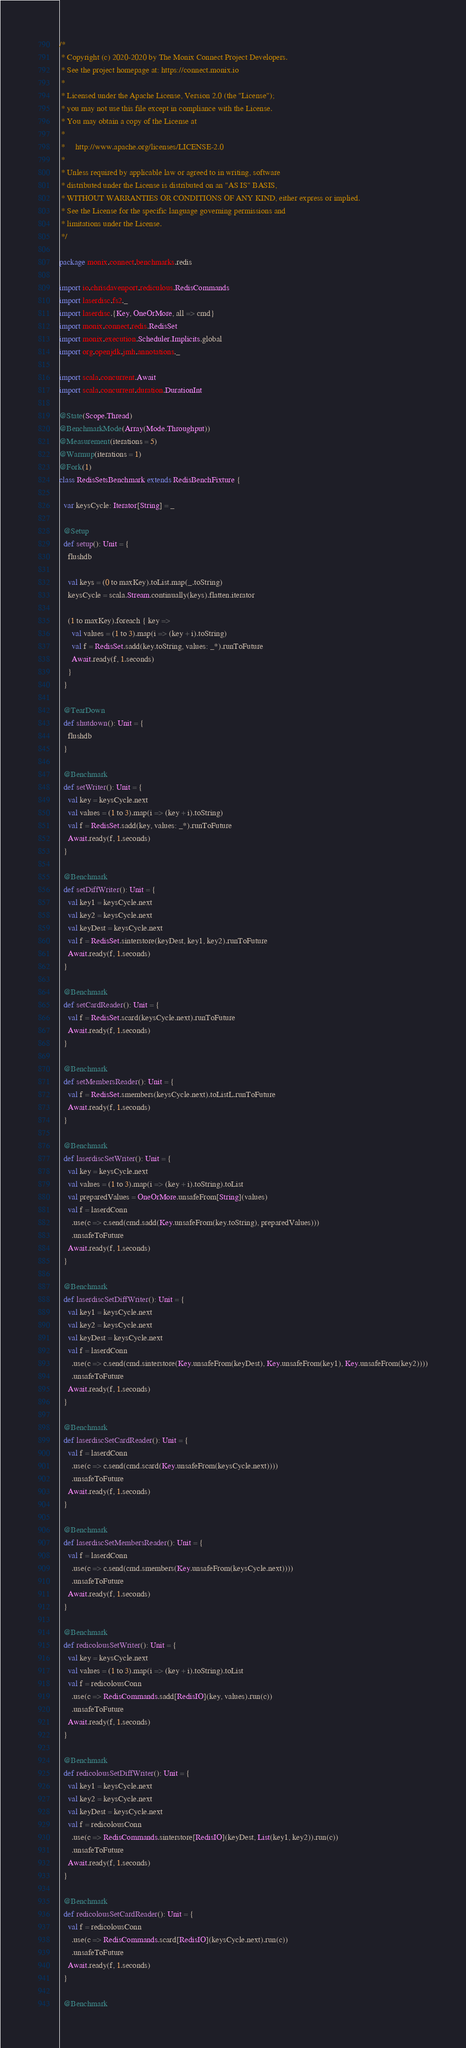Convert code to text. <code><loc_0><loc_0><loc_500><loc_500><_Scala_>/*
 * Copyright (c) 2020-2020 by The Monix Connect Project Developers.
 * See the project homepage at: https://connect.monix.io
 *
 * Licensed under the Apache License, Version 2.0 (the "License");
 * you may not use this file except in compliance with the License.
 * You may obtain a copy of the License at
 *
 *     http://www.apache.org/licenses/LICENSE-2.0
 *
 * Unless required by applicable law or agreed to in writing, software
 * distributed under the License is distributed on an "AS IS" BASIS,
 * WITHOUT WARRANTIES OR CONDITIONS OF ANY KIND, either express or implied.
 * See the License for the specific language governing permissions and
 * limitations under the License.
 */

package monix.connect.benchmarks.redis

import io.chrisdavenport.rediculous.RedisCommands
import laserdisc.fs2._
import laserdisc.{Key, OneOrMore, all => cmd}
import monix.connect.redis.RedisSet
import monix.execution.Scheduler.Implicits.global
import org.openjdk.jmh.annotations._

import scala.concurrent.Await
import scala.concurrent.duration.DurationInt

@State(Scope.Thread)
@BenchmarkMode(Array(Mode.Throughput))
@Measurement(iterations = 5)
@Warmup(iterations = 1)
@Fork(1)
class RedisSetsBenchmark extends RedisBenchFixture {

  var keysCycle: Iterator[String] = _

  @Setup
  def setup(): Unit = {
    flushdb

    val keys = (0 to maxKey).toList.map(_.toString)
    keysCycle = scala.Stream.continually(keys).flatten.iterator

    (1 to maxKey).foreach { key =>
      val values = (1 to 3).map(i => (key + i).toString)
      val f = RedisSet.sadd(key.toString, values: _*).runToFuture
      Await.ready(f, 1.seconds)
    }
  }

  @TearDown
  def shutdown(): Unit = {
    flushdb
  }

  @Benchmark
  def setWriter(): Unit = {
    val key = keysCycle.next
    val values = (1 to 3).map(i => (key + i).toString)
    val f = RedisSet.sadd(key, values: _*).runToFuture
    Await.ready(f, 1.seconds)
  }

  @Benchmark
  def setDiffWriter(): Unit = {
    val key1 = keysCycle.next
    val key2 = keysCycle.next
    val keyDest = keysCycle.next
    val f = RedisSet.sinterstore(keyDest, key1, key2).runToFuture
    Await.ready(f, 1.seconds)
  }

  @Benchmark
  def setCardReader(): Unit = {
    val f = RedisSet.scard(keysCycle.next).runToFuture
    Await.ready(f, 1.seconds)
  }

  @Benchmark
  def setMembersReader(): Unit = {
    val f = RedisSet.smembers(keysCycle.next).toListL.runToFuture
    Await.ready(f, 1.seconds)
  }

  @Benchmark
  def laserdiscSetWriter(): Unit = {
    val key = keysCycle.next
    val values = (1 to 3).map(i => (key + i).toString).toList
    val preparedValues = OneOrMore.unsafeFrom[String](values)
    val f = laserdConn
      .use(c => c.send(cmd.sadd(Key.unsafeFrom(key.toString), preparedValues)))
      .unsafeToFuture
    Await.ready(f, 1.seconds)
  }

  @Benchmark
  def laserdiscSetDiffWriter(): Unit = {
    val key1 = keysCycle.next
    val key2 = keysCycle.next
    val keyDest = keysCycle.next
    val f = laserdConn
      .use(c => c.send(cmd.sinterstore(Key.unsafeFrom(keyDest), Key.unsafeFrom(key1), Key.unsafeFrom(key2))))
      .unsafeToFuture
    Await.ready(f, 1.seconds)
  }

  @Benchmark
  def laserdiscSetCardReader(): Unit = {
    val f = laserdConn
      .use(c => c.send(cmd.scard(Key.unsafeFrom(keysCycle.next))))
      .unsafeToFuture
    Await.ready(f, 1.seconds)
  }

  @Benchmark
  def laserdiscSetMembersReader(): Unit = {
    val f = laserdConn
      .use(c => c.send(cmd.smembers(Key.unsafeFrom(keysCycle.next))))
      .unsafeToFuture
    Await.ready(f, 1.seconds)
  }

  @Benchmark
  def redicolousSetWriter(): Unit = {
    val key = keysCycle.next
    val values = (1 to 3).map(i => (key + i).toString).toList
    val f = redicolousConn
      .use(c => RedisCommands.sadd[RedisIO](key, values).run(c))
      .unsafeToFuture
    Await.ready(f, 1.seconds)
  }

  @Benchmark
  def redicolousSetDiffWriter(): Unit = {
    val key1 = keysCycle.next
    val key2 = keysCycle.next
    val keyDest = keysCycle.next
    val f = redicolousConn
      .use(c => RedisCommands.sinterstore[RedisIO](keyDest, List(key1, key2)).run(c))
      .unsafeToFuture
    Await.ready(f, 1.seconds)
  }

  @Benchmark
  def redicolousSetCardReader(): Unit = {
    val f = redicolousConn
      .use(c => RedisCommands.scard[RedisIO](keysCycle.next).run(c))
      .unsafeToFuture
    Await.ready(f, 1.seconds)
  }

  @Benchmark</code> 